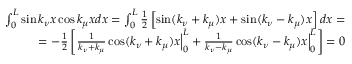<formula> <loc_0><loc_0><loc_500><loc_500>\begin{array} { r l r } & { \int _ { 0 } ^ { L } \sin k _ { \nu } x \cos k _ { \mu } x d x = \int _ { 0 } ^ { L } \frac { 1 } { 2 } \left [ \sin ( k _ { \nu } + k _ { \mu } ) x + \sin ( k _ { \nu } - k _ { \mu } ) x \right ] d x = } \\ & { \, = - \frac { 1 } { 2 } \left [ \frac { 1 } { k _ { \nu } + k _ { \mu } } \cos ( k _ { \nu } + k _ { \mu } ) x \left | _ { 0 } ^ { L } + \frac { 1 } { k _ { \nu } - k _ { \mu } } \cos ( k _ { \nu } - k _ { \mu } ) x \right | _ { 0 } ^ { L } \right ] = 0 } \end{array}</formula> 